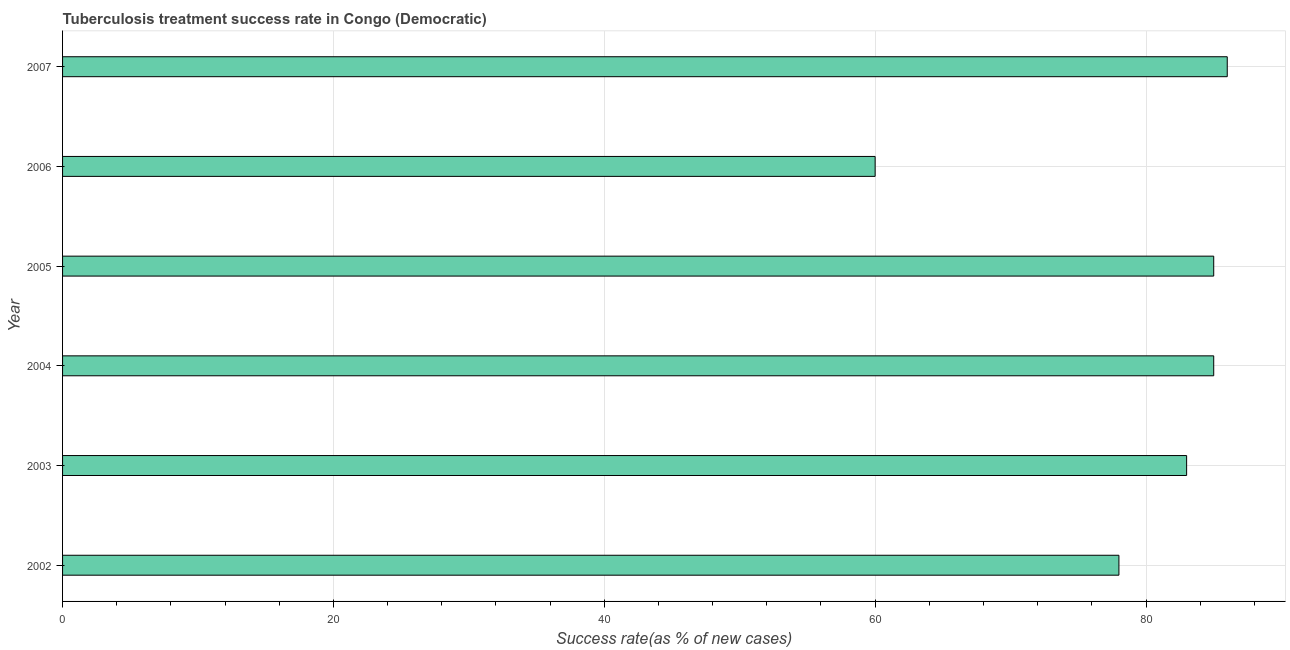Does the graph contain any zero values?
Your answer should be compact. No. What is the title of the graph?
Your answer should be very brief. Tuberculosis treatment success rate in Congo (Democratic). What is the label or title of the X-axis?
Ensure brevity in your answer.  Success rate(as % of new cases). What is the tuberculosis treatment success rate in 2003?
Offer a terse response. 83. Across all years, what is the maximum tuberculosis treatment success rate?
Your answer should be very brief. 86. Across all years, what is the minimum tuberculosis treatment success rate?
Your answer should be compact. 60. In which year was the tuberculosis treatment success rate maximum?
Offer a terse response. 2007. What is the sum of the tuberculosis treatment success rate?
Give a very brief answer. 477. What is the average tuberculosis treatment success rate per year?
Provide a short and direct response. 79. Do a majority of the years between 2004 and 2005 (inclusive) have tuberculosis treatment success rate greater than 48 %?
Give a very brief answer. Yes. What is the ratio of the tuberculosis treatment success rate in 2004 to that in 2005?
Provide a short and direct response. 1. Is the tuberculosis treatment success rate in 2002 less than that in 2004?
Your response must be concise. Yes. Is the sum of the tuberculosis treatment success rate in 2003 and 2004 greater than the maximum tuberculosis treatment success rate across all years?
Your response must be concise. Yes. What is the difference between the highest and the lowest tuberculosis treatment success rate?
Offer a terse response. 26. How many bars are there?
Offer a very short reply. 6. Are all the bars in the graph horizontal?
Provide a short and direct response. Yes. How many years are there in the graph?
Ensure brevity in your answer.  6. What is the difference between two consecutive major ticks on the X-axis?
Keep it short and to the point. 20. Are the values on the major ticks of X-axis written in scientific E-notation?
Your response must be concise. No. What is the Success rate(as % of new cases) of 2003?
Provide a short and direct response. 83. What is the Success rate(as % of new cases) of 2006?
Keep it short and to the point. 60. What is the difference between the Success rate(as % of new cases) in 2002 and 2003?
Give a very brief answer. -5. What is the difference between the Success rate(as % of new cases) in 2002 and 2005?
Your answer should be compact. -7. What is the difference between the Success rate(as % of new cases) in 2002 and 2006?
Your response must be concise. 18. What is the difference between the Success rate(as % of new cases) in 2003 and 2005?
Your response must be concise. -2. What is the difference between the Success rate(as % of new cases) in 2004 and 2006?
Give a very brief answer. 25. What is the difference between the Success rate(as % of new cases) in 2004 and 2007?
Give a very brief answer. -1. What is the difference between the Success rate(as % of new cases) in 2006 and 2007?
Keep it short and to the point. -26. What is the ratio of the Success rate(as % of new cases) in 2002 to that in 2004?
Your answer should be compact. 0.92. What is the ratio of the Success rate(as % of new cases) in 2002 to that in 2005?
Your answer should be very brief. 0.92. What is the ratio of the Success rate(as % of new cases) in 2002 to that in 2007?
Give a very brief answer. 0.91. What is the ratio of the Success rate(as % of new cases) in 2003 to that in 2004?
Offer a terse response. 0.98. What is the ratio of the Success rate(as % of new cases) in 2003 to that in 2005?
Ensure brevity in your answer.  0.98. What is the ratio of the Success rate(as % of new cases) in 2003 to that in 2006?
Provide a short and direct response. 1.38. What is the ratio of the Success rate(as % of new cases) in 2004 to that in 2006?
Your answer should be compact. 1.42. What is the ratio of the Success rate(as % of new cases) in 2005 to that in 2006?
Offer a very short reply. 1.42. What is the ratio of the Success rate(as % of new cases) in 2006 to that in 2007?
Give a very brief answer. 0.7. 